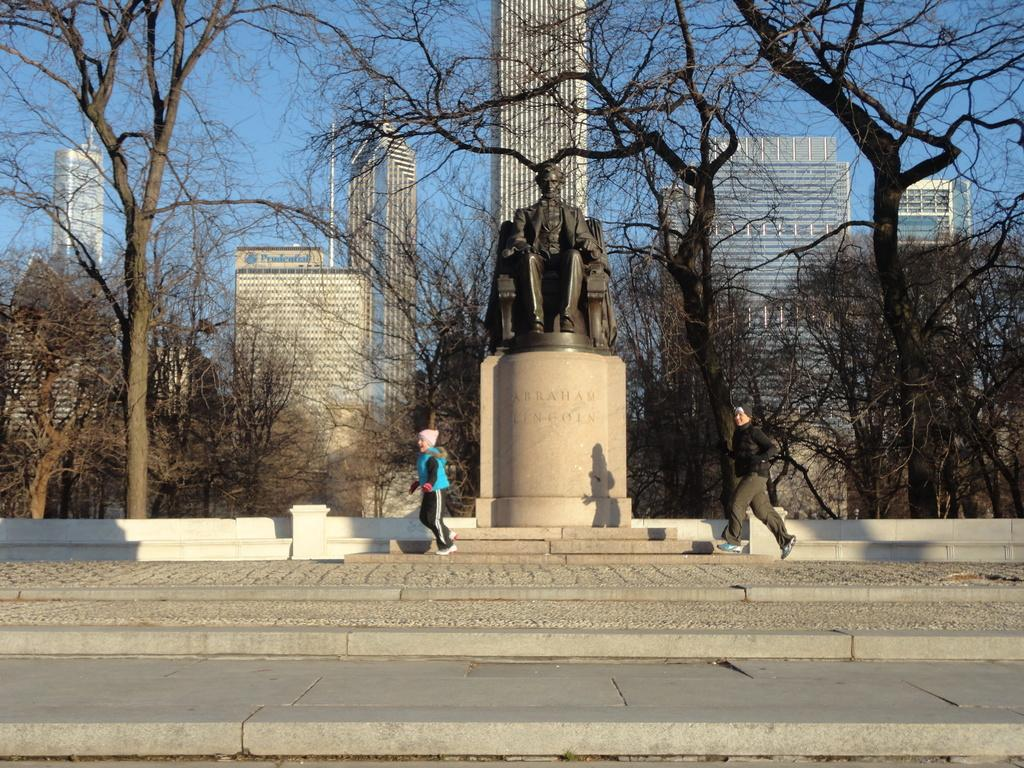What are the two persons in the image doing? The two persons in the image are running. What can be seen in the middle of the image besides the running persons? There is a statue in the image. What type of natural environment is visible in the background of the image? There are trees in the background of the image. What type of man-made structures can be seen in the background of the image? There are buildings in the background of the image. What is visible at the top of the image? The sky is visible at the top of the image. What is the tendency of the airport in the image? There is no airport present in the image; it features two persons running, a statue, trees, buildings, and the sky. 